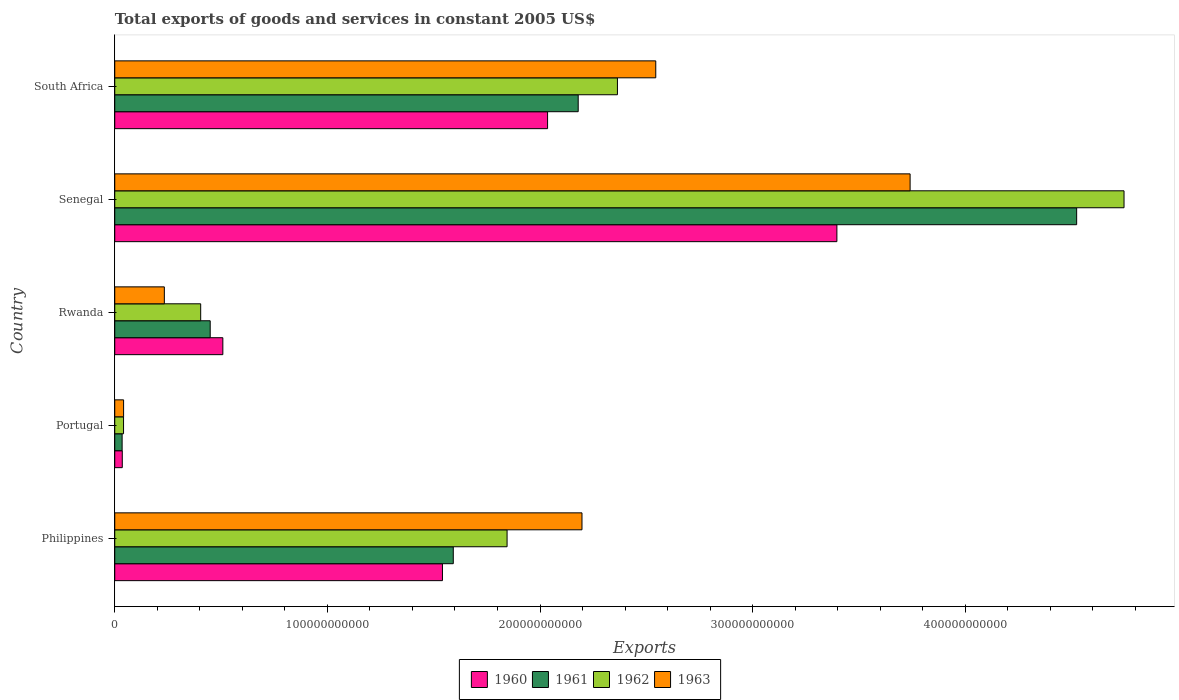How many groups of bars are there?
Make the answer very short. 5. Are the number of bars on each tick of the Y-axis equal?
Keep it short and to the point. Yes. How many bars are there on the 3rd tick from the bottom?
Your answer should be very brief. 4. What is the label of the 1st group of bars from the top?
Ensure brevity in your answer.  South Africa. In how many cases, is the number of bars for a given country not equal to the number of legend labels?
Give a very brief answer. 0. What is the total exports of goods and services in 1963 in Senegal?
Offer a very short reply. 3.74e+11. Across all countries, what is the maximum total exports of goods and services in 1960?
Provide a short and direct response. 3.40e+11. Across all countries, what is the minimum total exports of goods and services in 1961?
Make the answer very short. 3.47e+09. In which country was the total exports of goods and services in 1962 maximum?
Keep it short and to the point. Senegal. In which country was the total exports of goods and services in 1963 minimum?
Offer a terse response. Portugal. What is the total total exports of goods and services in 1960 in the graph?
Offer a very short reply. 7.52e+11. What is the difference between the total exports of goods and services in 1962 in Senegal and that in South Africa?
Keep it short and to the point. 2.38e+11. What is the difference between the total exports of goods and services in 1962 in Rwanda and the total exports of goods and services in 1960 in Philippines?
Provide a short and direct response. -1.14e+11. What is the average total exports of goods and services in 1961 per country?
Your response must be concise. 1.76e+11. What is the difference between the total exports of goods and services in 1960 and total exports of goods and services in 1961 in Senegal?
Provide a short and direct response. -1.13e+11. What is the ratio of the total exports of goods and services in 1963 in Philippines to that in Portugal?
Your answer should be compact. 52.88. Is the total exports of goods and services in 1960 in Portugal less than that in Rwanda?
Your answer should be very brief. Yes. What is the difference between the highest and the second highest total exports of goods and services in 1962?
Offer a very short reply. 2.38e+11. What is the difference between the highest and the lowest total exports of goods and services in 1961?
Give a very brief answer. 4.49e+11. Is it the case that in every country, the sum of the total exports of goods and services in 1962 and total exports of goods and services in 1961 is greater than the sum of total exports of goods and services in 1960 and total exports of goods and services in 1963?
Provide a short and direct response. No. What does the 2nd bar from the bottom in Portugal represents?
Provide a short and direct response. 1961. How many bars are there?
Make the answer very short. 20. Are all the bars in the graph horizontal?
Provide a short and direct response. Yes. What is the difference between two consecutive major ticks on the X-axis?
Ensure brevity in your answer.  1.00e+11. Are the values on the major ticks of X-axis written in scientific E-notation?
Keep it short and to the point. No. Does the graph contain any zero values?
Give a very brief answer. No. How many legend labels are there?
Your answer should be very brief. 4. How are the legend labels stacked?
Keep it short and to the point. Horizontal. What is the title of the graph?
Your answer should be compact. Total exports of goods and services in constant 2005 US$. Does "1995" appear as one of the legend labels in the graph?
Make the answer very short. No. What is the label or title of the X-axis?
Provide a succinct answer. Exports. What is the Exports of 1960 in Philippines?
Your answer should be compact. 1.54e+11. What is the Exports of 1961 in Philippines?
Offer a terse response. 1.59e+11. What is the Exports of 1962 in Philippines?
Give a very brief answer. 1.85e+11. What is the Exports of 1963 in Philippines?
Offer a terse response. 2.20e+11. What is the Exports of 1960 in Portugal?
Your response must be concise. 3.54e+09. What is the Exports of 1961 in Portugal?
Your answer should be compact. 3.47e+09. What is the Exports of 1962 in Portugal?
Ensure brevity in your answer.  4.13e+09. What is the Exports of 1963 in Portugal?
Your response must be concise. 4.16e+09. What is the Exports in 1960 in Rwanda?
Give a very brief answer. 5.08e+1. What is the Exports in 1961 in Rwanda?
Provide a short and direct response. 4.49e+1. What is the Exports of 1962 in Rwanda?
Give a very brief answer. 4.04e+1. What is the Exports of 1963 in Rwanda?
Keep it short and to the point. 2.33e+1. What is the Exports in 1960 in Senegal?
Your answer should be compact. 3.40e+11. What is the Exports of 1961 in Senegal?
Provide a succinct answer. 4.52e+11. What is the Exports of 1962 in Senegal?
Your response must be concise. 4.75e+11. What is the Exports in 1963 in Senegal?
Make the answer very short. 3.74e+11. What is the Exports in 1960 in South Africa?
Make the answer very short. 2.04e+11. What is the Exports in 1961 in South Africa?
Your answer should be very brief. 2.18e+11. What is the Exports in 1962 in South Africa?
Make the answer very short. 2.36e+11. What is the Exports of 1963 in South Africa?
Your response must be concise. 2.54e+11. Across all countries, what is the maximum Exports in 1960?
Provide a succinct answer. 3.40e+11. Across all countries, what is the maximum Exports in 1961?
Offer a terse response. 4.52e+11. Across all countries, what is the maximum Exports of 1962?
Offer a terse response. 4.75e+11. Across all countries, what is the maximum Exports in 1963?
Keep it short and to the point. 3.74e+11. Across all countries, what is the minimum Exports of 1960?
Offer a terse response. 3.54e+09. Across all countries, what is the minimum Exports in 1961?
Provide a short and direct response. 3.47e+09. Across all countries, what is the minimum Exports in 1962?
Keep it short and to the point. 4.13e+09. Across all countries, what is the minimum Exports in 1963?
Offer a very short reply. 4.16e+09. What is the total Exports of 1960 in the graph?
Provide a succinct answer. 7.52e+11. What is the total Exports in 1961 in the graph?
Your answer should be very brief. 8.78e+11. What is the total Exports of 1962 in the graph?
Your answer should be very brief. 9.40e+11. What is the total Exports of 1963 in the graph?
Give a very brief answer. 8.76e+11. What is the difference between the Exports in 1960 in Philippines and that in Portugal?
Offer a very short reply. 1.51e+11. What is the difference between the Exports in 1961 in Philippines and that in Portugal?
Keep it short and to the point. 1.56e+11. What is the difference between the Exports of 1962 in Philippines and that in Portugal?
Your answer should be compact. 1.80e+11. What is the difference between the Exports in 1963 in Philippines and that in Portugal?
Provide a succinct answer. 2.16e+11. What is the difference between the Exports in 1960 in Philippines and that in Rwanda?
Offer a terse response. 1.03e+11. What is the difference between the Exports of 1961 in Philippines and that in Rwanda?
Ensure brevity in your answer.  1.14e+11. What is the difference between the Exports in 1962 in Philippines and that in Rwanda?
Offer a very short reply. 1.44e+11. What is the difference between the Exports in 1963 in Philippines and that in Rwanda?
Offer a very short reply. 1.96e+11. What is the difference between the Exports in 1960 in Philippines and that in Senegal?
Provide a succinct answer. -1.85e+11. What is the difference between the Exports of 1961 in Philippines and that in Senegal?
Provide a succinct answer. -2.93e+11. What is the difference between the Exports of 1962 in Philippines and that in Senegal?
Your answer should be compact. -2.90e+11. What is the difference between the Exports of 1963 in Philippines and that in Senegal?
Your answer should be very brief. -1.54e+11. What is the difference between the Exports in 1960 in Philippines and that in South Africa?
Your answer should be compact. -4.94e+1. What is the difference between the Exports in 1961 in Philippines and that in South Africa?
Make the answer very short. -5.87e+1. What is the difference between the Exports in 1962 in Philippines and that in South Africa?
Offer a terse response. -5.19e+1. What is the difference between the Exports of 1963 in Philippines and that in South Africa?
Keep it short and to the point. -3.47e+1. What is the difference between the Exports of 1960 in Portugal and that in Rwanda?
Offer a terse response. -4.73e+1. What is the difference between the Exports of 1961 in Portugal and that in Rwanda?
Give a very brief answer. -4.14e+1. What is the difference between the Exports in 1962 in Portugal and that in Rwanda?
Your answer should be compact. -3.63e+1. What is the difference between the Exports of 1963 in Portugal and that in Rwanda?
Offer a terse response. -1.92e+1. What is the difference between the Exports of 1960 in Portugal and that in Senegal?
Make the answer very short. -3.36e+11. What is the difference between the Exports of 1961 in Portugal and that in Senegal?
Make the answer very short. -4.49e+11. What is the difference between the Exports in 1962 in Portugal and that in Senegal?
Offer a very short reply. -4.71e+11. What is the difference between the Exports of 1963 in Portugal and that in Senegal?
Your answer should be very brief. -3.70e+11. What is the difference between the Exports of 1960 in Portugal and that in South Africa?
Keep it short and to the point. -2.00e+11. What is the difference between the Exports in 1961 in Portugal and that in South Africa?
Provide a succinct answer. -2.14e+11. What is the difference between the Exports in 1962 in Portugal and that in South Africa?
Offer a very short reply. -2.32e+11. What is the difference between the Exports of 1963 in Portugal and that in South Africa?
Provide a succinct answer. -2.50e+11. What is the difference between the Exports of 1960 in Rwanda and that in Senegal?
Provide a short and direct response. -2.89e+11. What is the difference between the Exports of 1961 in Rwanda and that in Senegal?
Ensure brevity in your answer.  -4.07e+11. What is the difference between the Exports in 1962 in Rwanda and that in Senegal?
Provide a short and direct response. -4.34e+11. What is the difference between the Exports of 1963 in Rwanda and that in Senegal?
Offer a terse response. -3.51e+11. What is the difference between the Exports in 1960 in Rwanda and that in South Africa?
Offer a terse response. -1.53e+11. What is the difference between the Exports of 1961 in Rwanda and that in South Africa?
Keep it short and to the point. -1.73e+11. What is the difference between the Exports in 1962 in Rwanda and that in South Africa?
Your response must be concise. -1.96e+11. What is the difference between the Exports of 1963 in Rwanda and that in South Africa?
Make the answer very short. -2.31e+11. What is the difference between the Exports in 1960 in Senegal and that in South Africa?
Provide a succinct answer. 1.36e+11. What is the difference between the Exports in 1961 in Senegal and that in South Africa?
Offer a very short reply. 2.34e+11. What is the difference between the Exports in 1962 in Senegal and that in South Africa?
Provide a short and direct response. 2.38e+11. What is the difference between the Exports in 1963 in Senegal and that in South Africa?
Ensure brevity in your answer.  1.20e+11. What is the difference between the Exports in 1960 in Philippines and the Exports in 1961 in Portugal?
Your answer should be very brief. 1.51e+11. What is the difference between the Exports in 1960 in Philippines and the Exports in 1962 in Portugal?
Offer a terse response. 1.50e+11. What is the difference between the Exports of 1960 in Philippines and the Exports of 1963 in Portugal?
Offer a terse response. 1.50e+11. What is the difference between the Exports of 1961 in Philippines and the Exports of 1962 in Portugal?
Give a very brief answer. 1.55e+11. What is the difference between the Exports of 1961 in Philippines and the Exports of 1963 in Portugal?
Make the answer very short. 1.55e+11. What is the difference between the Exports of 1962 in Philippines and the Exports of 1963 in Portugal?
Your response must be concise. 1.80e+11. What is the difference between the Exports of 1960 in Philippines and the Exports of 1961 in Rwanda?
Provide a succinct answer. 1.09e+11. What is the difference between the Exports in 1960 in Philippines and the Exports in 1962 in Rwanda?
Keep it short and to the point. 1.14e+11. What is the difference between the Exports of 1960 in Philippines and the Exports of 1963 in Rwanda?
Provide a succinct answer. 1.31e+11. What is the difference between the Exports in 1961 in Philippines and the Exports in 1962 in Rwanda?
Offer a very short reply. 1.19e+11. What is the difference between the Exports of 1961 in Philippines and the Exports of 1963 in Rwanda?
Your answer should be compact. 1.36e+11. What is the difference between the Exports of 1962 in Philippines and the Exports of 1963 in Rwanda?
Keep it short and to the point. 1.61e+11. What is the difference between the Exports in 1960 in Philippines and the Exports in 1961 in Senegal?
Your response must be concise. -2.98e+11. What is the difference between the Exports of 1960 in Philippines and the Exports of 1962 in Senegal?
Keep it short and to the point. -3.21e+11. What is the difference between the Exports of 1960 in Philippines and the Exports of 1963 in Senegal?
Ensure brevity in your answer.  -2.20e+11. What is the difference between the Exports in 1961 in Philippines and the Exports in 1962 in Senegal?
Ensure brevity in your answer.  -3.15e+11. What is the difference between the Exports in 1961 in Philippines and the Exports in 1963 in Senegal?
Offer a very short reply. -2.15e+11. What is the difference between the Exports in 1962 in Philippines and the Exports in 1963 in Senegal?
Provide a succinct answer. -1.90e+11. What is the difference between the Exports of 1960 in Philippines and the Exports of 1961 in South Africa?
Your answer should be compact. -6.38e+1. What is the difference between the Exports of 1960 in Philippines and the Exports of 1962 in South Africa?
Make the answer very short. -8.23e+1. What is the difference between the Exports of 1960 in Philippines and the Exports of 1963 in South Africa?
Keep it short and to the point. -1.00e+11. What is the difference between the Exports of 1961 in Philippines and the Exports of 1962 in South Africa?
Your answer should be compact. -7.72e+1. What is the difference between the Exports in 1961 in Philippines and the Exports in 1963 in South Africa?
Make the answer very short. -9.52e+1. What is the difference between the Exports in 1962 in Philippines and the Exports in 1963 in South Africa?
Ensure brevity in your answer.  -6.99e+1. What is the difference between the Exports of 1960 in Portugal and the Exports of 1961 in Rwanda?
Provide a succinct answer. -4.13e+1. What is the difference between the Exports of 1960 in Portugal and the Exports of 1962 in Rwanda?
Your answer should be very brief. -3.69e+1. What is the difference between the Exports in 1960 in Portugal and the Exports in 1963 in Rwanda?
Give a very brief answer. -1.98e+1. What is the difference between the Exports of 1961 in Portugal and the Exports of 1962 in Rwanda?
Your answer should be compact. -3.69e+1. What is the difference between the Exports in 1961 in Portugal and the Exports in 1963 in Rwanda?
Your answer should be compact. -1.99e+1. What is the difference between the Exports of 1962 in Portugal and the Exports of 1963 in Rwanda?
Keep it short and to the point. -1.92e+1. What is the difference between the Exports of 1960 in Portugal and the Exports of 1961 in Senegal?
Provide a succinct answer. -4.49e+11. What is the difference between the Exports of 1960 in Portugal and the Exports of 1962 in Senegal?
Your answer should be compact. -4.71e+11. What is the difference between the Exports of 1960 in Portugal and the Exports of 1963 in Senegal?
Provide a succinct answer. -3.70e+11. What is the difference between the Exports in 1961 in Portugal and the Exports in 1962 in Senegal?
Provide a short and direct response. -4.71e+11. What is the difference between the Exports of 1961 in Portugal and the Exports of 1963 in Senegal?
Offer a terse response. -3.71e+11. What is the difference between the Exports in 1962 in Portugal and the Exports in 1963 in Senegal?
Keep it short and to the point. -3.70e+11. What is the difference between the Exports of 1960 in Portugal and the Exports of 1961 in South Africa?
Your response must be concise. -2.14e+11. What is the difference between the Exports of 1960 in Portugal and the Exports of 1962 in South Africa?
Your answer should be very brief. -2.33e+11. What is the difference between the Exports of 1960 in Portugal and the Exports of 1963 in South Africa?
Offer a very short reply. -2.51e+11. What is the difference between the Exports in 1961 in Portugal and the Exports in 1962 in South Africa?
Provide a succinct answer. -2.33e+11. What is the difference between the Exports of 1961 in Portugal and the Exports of 1963 in South Africa?
Offer a very short reply. -2.51e+11. What is the difference between the Exports in 1962 in Portugal and the Exports in 1963 in South Africa?
Your answer should be very brief. -2.50e+11. What is the difference between the Exports in 1960 in Rwanda and the Exports in 1961 in Senegal?
Make the answer very short. -4.02e+11. What is the difference between the Exports in 1960 in Rwanda and the Exports in 1962 in Senegal?
Give a very brief answer. -4.24e+11. What is the difference between the Exports in 1960 in Rwanda and the Exports in 1963 in Senegal?
Your answer should be compact. -3.23e+11. What is the difference between the Exports in 1961 in Rwanda and the Exports in 1962 in Senegal?
Keep it short and to the point. -4.30e+11. What is the difference between the Exports of 1961 in Rwanda and the Exports of 1963 in Senegal?
Keep it short and to the point. -3.29e+11. What is the difference between the Exports in 1962 in Rwanda and the Exports in 1963 in Senegal?
Offer a terse response. -3.34e+11. What is the difference between the Exports of 1960 in Rwanda and the Exports of 1961 in South Africa?
Offer a very short reply. -1.67e+11. What is the difference between the Exports in 1960 in Rwanda and the Exports in 1962 in South Africa?
Make the answer very short. -1.86e+11. What is the difference between the Exports of 1960 in Rwanda and the Exports of 1963 in South Africa?
Your answer should be compact. -2.04e+11. What is the difference between the Exports of 1961 in Rwanda and the Exports of 1962 in South Africa?
Provide a succinct answer. -1.92e+11. What is the difference between the Exports in 1961 in Rwanda and the Exports in 1963 in South Africa?
Offer a terse response. -2.10e+11. What is the difference between the Exports of 1962 in Rwanda and the Exports of 1963 in South Africa?
Your response must be concise. -2.14e+11. What is the difference between the Exports of 1960 in Senegal and the Exports of 1961 in South Africa?
Your answer should be compact. 1.22e+11. What is the difference between the Exports of 1960 in Senegal and the Exports of 1962 in South Africa?
Make the answer very short. 1.03e+11. What is the difference between the Exports of 1960 in Senegal and the Exports of 1963 in South Africa?
Provide a succinct answer. 8.52e+1. What is the difference between the Exports in 1961 in Senegal and the Exports in 1962 in South Africa?
Your answer should be very brief. 2.16e+11. What is the difference between the Exports in 1961 in Senegal and the Exports in 1963 in South Africa?
Offer a terse response. 1.98e+11. What is the difference between the Exports in 1962 in Senegal and the Exports in 1963 in South Africa?
Give a very brief answer. 2.20e+11. What is the average Exports of 1960 per country?
Provide a succinct answer. 1.50e+11. What is the average Exports in 1961 per country?
Offer a very short reply. 1.76e+11. What is the average Exports of 1962 per country?
Ensure brevity in your answer.  1.88e+11. What is the average Exports in 1963 per country?
Your answer should be very brief. 1.75e+11. What is the difference between the Exports of 1960 and Exports of 1961 in Philippines?
Keep it short and to the point. -5.10e+09. What is the difference between the Exports in 1960 and Exports in 1962 in Philippines?
Provide a short and direct response. -3.04e+1. What is the difference between the Exports in 1960 and Exports in 1963 in Philippines?
Your answer should be very brief. -6.56e+1. What is the difference between the Exports in 1961 and Exports in 1962 in Philippines?
Provide a succinct answer. -2.53e+1. What is the difference between the Exports in 1961 and Exports in 1963 in Philippines?
Make the answer very short. -6.05e+1. What is the difference between the Exports in 1962 and Exports in 1963 in Philippines?
Provide a succinct answer. -3.52e+1. What is the difference between the Exports of 1960 and Exports of 1961 in Portugal?
Keep it short and to the point. 7.38e+07. What is the difference between the Exports in 1960 and Exports in 1962 in Portugal?
Provide a short and direct response. -5.90e+08. What is the difference between the Exports of 1960 and Exports of 1963 in Portugal?
Offer a terse response. -6.15e+08. What is the difference between the Exports of 1961 and Exports of 1962 in Portugal?
Ensure brevity in your answer.  -6.64e+08. What is the difference between the Exports in 1961 and Exports in 1963 in Portugal?
Your response must be concise. -6.88e+08. What is the difference between the Exports of 1962 and Exports of 1963 in Portugal?
Make the answer very short. -2.46e+07. What is the difference between the Exports in 1960 and Exports in 1961 in Rwanda?
Provide a succinct answer. 5.95e+09. What is the difference between the Exports in 1960 and Exports in 1962 in Rwanda?
Your answer should be very brief. 1.04e+1. What is the difference between the Exports of 1960 and Exports of 1963 in Rwanda?
Offer a very short reply. 2.75e+1. What is the difference between the Exports in 1961 and Exports in 1962 in Rwanda?
Ensure brevity in your answer.  4.47e+09. What is the difference between the Exports of 1961 and Exports of 1963 in Rwanda?
Keep it short and to the point. 2.16e+1. What is the difference between the Exports in 1962 and Exports in 1963 in Rwanda?
Your answer should be very brief. 1.71e+1. What is the difference between the Exports in 1960 and Exports in 1961 in Senegal?
Offer a very short reply. -1.13e+11. What is the difference between the Exports of 1960 and Exports of 1962 in Senegal?
Provide a succinct answer. -1.35e+11. What is the difference between the Exports of 1960 and Exports of 1963 in Senegal?
Ensure brevity in your answer.  -3.44e+1. What is the difference between the Exports of 1961 and Exports of 1962 in Senegal?
Give a very brief answer. -2.23e+1. What is the difference between the Exports of 1961 and Exports of 1963 in Senegal?
Your answer should be compact. 7.83e+1. What is the difference between the Exports in 1962 and Exports in 1963 in Senegal?
Give a very brief answer. 1.01e+11. What is the difference between the Exports in 1960 and Exports in 1961 in South Africa?
Make the answer very short. -1.44e+1. What is the difference between the Exports in 1960 and Exports in 1962 in South Africa?
Offer a terse response. -3.29e+1. What is the difference between the Exports of 1960 and Exports of 1963 in South Africa?
Provide a short and direct response. -5.09e+1. What is the difference between the Exports of 1961 and Exports of 1962 in South Africa?
Your answer should be compact. -1.85e+1. What is the difference between the Exports in 1961 and Exports in 1963 in South Africa?
Your answer should be compact. -3.65e+1. What is the difference between the Exports of 1962 and Exports of 1963 in South Africa?
Your response must be concise. -1.80e+1. What is the ratio of the Exports of 1960 in Philippines to that in Portugal?
Your answer should be very brief. 43.52. What is the ratio of the Exports in 1961 in Philippines to that in Portugal?
Keep it short and to the point. 45.92. What is the ratio of the Exports in 1962 in Philippines to that in Portugal?
Make the answer very short. 44.66. What is the ratio of the Exports of 1963 in Philippines to that in Portugal?
Offer a terse response. 52.88. What is the ratio of the Exports in 1960 in Philippines to that in Rwanda?
Provide a succinct answer. 3.03. What is the ratio of the Exports of 1961 in Philippines to that in Rwanda?
Offer a terse response. 3.55. What is the ratio of the Exports in 1962 in Philippines to that in Rwanda?
Your response must be concise. 4.57. What is the ratio of the Exports in 1963 in Philippines to that in Rwanda?
Offer a very short reply. 9.42. What is the ratio of the Exports of 1960 in Philippines to that in Senegal?
Ensure brevity in your answer.  0.45. What is the ratio of the Exports of 1961 in Philippines to that in Senegal?
Offer a very short reply. 0.35. What is the ratio of the Exports in 1962 in Philippines to that in Senegal?
Your response must be concise. 0.39. What is the ratio of the Exports of 1963 in Philippines to that in Senegal?
Keep it short and to the point. 0.59. What is the ratio of the Exports of 1960 in Philippines to that in South Africa?
Ensure brevity in your answer.  0.76. What is the ratio of the Exports of 1961 in Philippines to that in South Africa?
Provide a succinct answer. 0.73. What is the ratio of the Exports in 1962 in Philippines to that in South Africa?
Offer a very short reply. 0.78. What is the ratio of the Exports in 1963 in Philippines to that in South Africa?
Provide a short and direct response. 0.86. What is the ratio of the Exports in 1960 in Portugal to that in Rwanda?
Your answer should be very brief. 0.07. What is the ratio of the Exports of 1961 in Portugal to that in Rwanda?
Your response must be concise. 0.08. What is the ratio of the Exports of 1962 in Portugal to that in Rwanda?
Keep it short and to the point. 0.1. What is the ratio of the Exports of 1963 in Portugal to that in Rwanda?
Provide a short and direct response. 0.18. What is the ratio of the Exports in 1960 in Portugal to that in Senegal?
Your answer should be very brief. 0.01. What is the ratio of the Exports in 1961 in Portugal to that in Senegal?
Your answer should be very brief. 0.01. What is the ratio of the Exports in 1962 in Portugal to that in Senegal?
Provide a succinct answer. 0.01. What is the ratio of the Exports of 1963 in Portugal to that in Senegal?
Ensure brevity in your answer.  0.01. What is the ratio of the Exports of 1960 in Portugal to that in South Africa?
Ensure brevity in your answer.  0.02. What is the ratio of the Exports of 1961 in Portugal to that in South Africa?
Your answer should be compact. 0.02. What is the ratio of the Exports of 1962 in Portugal to that in South Africa?
Provide a short and direct response. 0.02. What is the ratio of the Exports of 1963 in Portugal to that in South Africa?
Give a very brief answer. 0.02. What is the ratio of the Exports of 1960 in Rwanda to that in Senegal?
Your answer should be compact. 0.15. What is the ratio of the Exports of 1961 in Rwanda to that in Senegal?
Your answer should be compact. 0.1. What is the ratio of the Exports of 1962 in Rwanda to that in Senegal?
Offer a terse response. 0.09. What is the ratio of the Exports of 1963 in Rwanda to that in Senegal?
Ensure brevity in your answer.  0.06. What is the ratio of the Exports in 1960 in Rwanda to that in South Africa?
Ensure brevity in your answer.  0.25. What is the ratio of the Exports of 1961 in Rwanda to that in South Africa?
Offer a terse response. 0.21. What is the ratio of the Exports of 1962 in Rwanda to that in South Africa?
Keep it short and to the point. 0.17. What is the ratio of the Exports of 1963 in Rwanda to that in South Africa?
Keep it short and to the point. 0.09. What is the ratio of the Exports in 1960 in Senegal to that in South Africa?
Your answer should be very brief. 1.67. What is the ratio of the Exports in 1961 in Senegal to that in South Africa?
Provide a short and direct response. 2.08. What is the ratio of the Exports of 1962 in Senegal to that in South Africa?
Your response must be concise. 2.01. What is the ratio of the Exports of 1963 in Senegal to that in South Africa?
Your response must be concise. 1.47. What is the difference between the highest and the second highest Exports in 1960?
Give a very brief answer. 1.36e+11. What is the difference between the highest and the second highest Exports in 1961?
Offer a terse response. 2.34e+11. What is the difference between the highest and the second highest Exports in 1962?
Offer a terse response. 2.38e+11. What is the difference between the highest and the second highest Exports of 1963?
Keep it short and to the point. 1.20e+11. What is the difference between the highest and the lowest Exports of 1960?
Your answer should be very brief. 3.36e+11. What is the difference between the highest and the lowest Exports of 1961?
Give a very brief answer. 4.49e+11. What is the difference between the highest and the lowest Exports in 1962?
Ensure brevity in your answer.  4.71e+11. What is the difference between the highest and the lowest Exports of 1963?
Offer a terse response. 3.70e+11. 